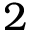<formula> <loc_0><loc_0><loc_500><loc_500>2</formula> 